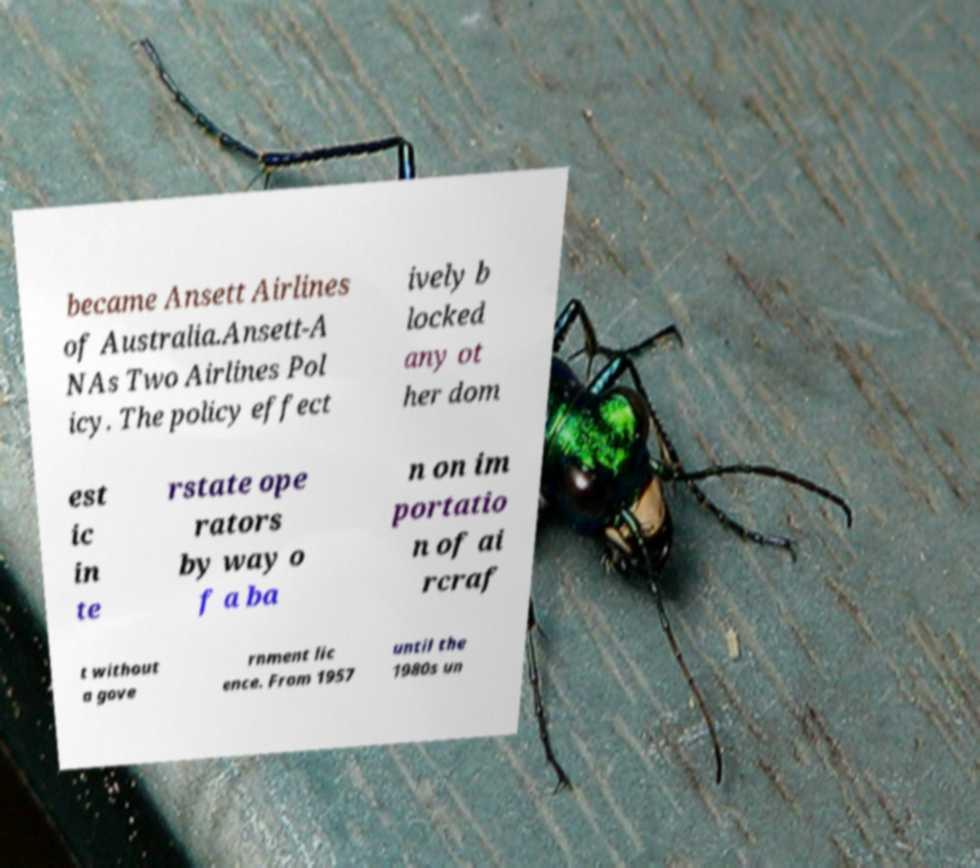There's text embedded in this image that I need extracted. Can you transcribe it verbatim? became Ansett Airlines of Australia.Ansett-A NAs Two Airlines Pol icy. The policy effect ively b locked any ot her dom est ic in te rstate ope rators by way o f a ba n on im portatio n of ai rcraf t without a gove rnment lic ence. From 1957 until the 1980s un 